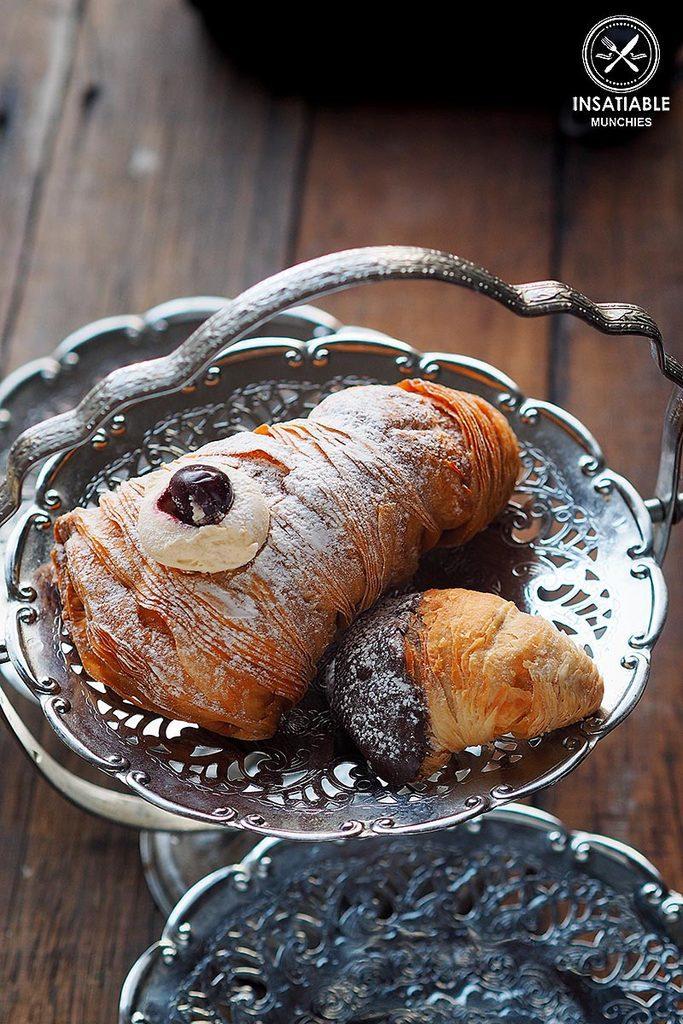In one or two sentences, can you explain what this image depicts? In this image we can see some food in a container. We can also see some containers which are placed on the table. 